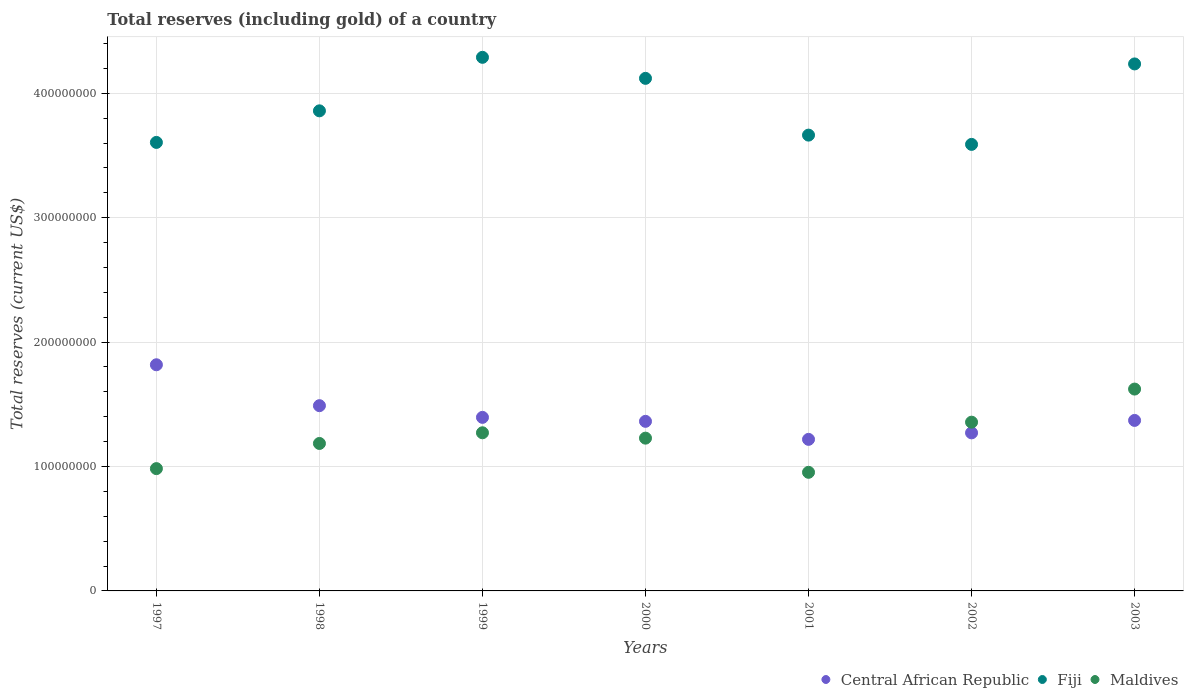What is the total reserves (including gold) in Fiji in 2001?
Offer a terse response. 3.66e+08. Across all years, what is the maximum total reserves (including gold) in Central African Republic?
Provide a short and direct response. 1.82e+08. Across all years, what is the minimum total reserves (including gold) in Fiji?
Your response must be concise. 3.59e+08. In which year was the total reserves (including gold) in Central African Republic minimum?
Offer a very short reply. 2001. What is the total total reserves (including gold) in Maldives in the graph?
Offer a very short reply. 8.60e+08. What is the difference between the total reserves (including gold) in Fiji in 2001 and that in 2003?
Give a very brief answer. -5.72e+07. What is the difference between the total reserves (including gold) in Fiji in 2001 and the total reserves (including gold) in Central African Republic in 2000?
Make the answer very short. 2.30e+08. What is the average total reserves (including gold) in Central African Republic per year?
Your answer should be compact. 1.42e+08. In the year 2003, what is the difference between the total reserves (including gold) in Fiji and total reserves (including gold) in Maldives?
Provide a short and direct response. 2.61e+08. What is the ratio of the total reserves (including gold) in Central African Republic in 1998 to that in 1999?
Provide a short and direct response. 1.07. Is the total reserves (including gold) in Central African Republic in 1998 less than that in 2001?
Keep it short and to the point. No. What is the difference between the highest and the second highest total reserves (including gold) in Fiji?
Provide a short and direct response. 5.31e+06. What is the difference between the highest and the lowest total reserves (including gold) in Central African Republic?
Give a very brief answer. 6.00e+07. In how many years, is the total reserves (including gold) in Fiji greater than the average total reserves (including gold) in Fiji taken over all years?
Keep it short and to the point. 3. Is the sum of the total reserves (including gold) in Maldives in 2001 and 2002 greater than the maximum total reserves (including gold) in Central African Republic across all years?
Keep it short and to the point. Yes. Does the total reserves (including gold) in Maldives monotonically increase over the years?
Give a very brief answer. No. Is the total reserves (including gold) in Fiji strictly greater than the total reserves (including gold) in Central African Republic over the years?
Make the answer very short. Yes. How many dotlines are there?
Your answer should be compact. 3. How many years are there in the graph?
Give a very brief answer. 7. Are the values on the major ticks of Y-axis written in scientific E-notation?
Your response must be concise. No. Does the graph contain grids?
Your answer should be compact. Yes. How are the legend labels stacked?
Your response must be concise. Horizontal. What is the title of the graph?
Provide a short and direct response. Total reserves (including gold) of a country. What is the label or title of the X-axis?
Your answer should be very brief. Years. What is the label or title of the Y-axis?
Your response must be concise. Total reserves (current US$). What is the Total reserves (current US$) of Central African Republic in 1997?
Offer a very short reply. 1.82e+08. What is the Total reserves (current US$) in Fiji in 1997?
Give a very brief answer. 3.61e+08. What is the Total reserves (current US$) of Maldives in 1997?
Offer a terse response. 9.83e+07. What is the Total reserves (current US$) in Central African Republic in 1998?
Ensure brevity in your answer.  1.49e+08. What is the Total reserves (current US$) in Fiji in 1998?
Offer a terse response. 3.86e+08. What is the Total reserves (current US$) of Maldives in 1998?
Provide a short and direct response. 1.19e+08. What is the Total reserves (current US$) of Central African Republic in 1999?
Give a very brief answer. 1.40e+08. What is the Total reserves (current US$) in Fiji in 1999?
Your answer should be very brief. 4.29e+08. What is the Total reserves (current US$) of Maldives in 1999?
Provide a short and direct response. 1.27e+08. What is the Total reserves (current US$) of Central African Republic in 2000?
Your answer should be compact. 1.36e+08. What is the Total reserves (current US$) of Fiji in 2000?
Provide a short and direct response. 4.12e+08. What is the Total reserves (current US$) of Maldives in 2000?
Offer a terse response. 1.23e+08. What is the Total reserves (current US$) of Central African Republic in 2001?
Offer a terse response. 1.22e+08. What is the Total reserves (current US$) in Fiji in 2001?
Offer a very short reply. 3.66e+08. What is the Total reserves (current US$) of Maldives in 2001?
Provide a succinct answer. 9.53e+07. What is the Total reserves (current US$) of Central African Republic in 2002?
Offer a terse response. 1.27e+08. What is the Total reserves (current US$) of Fiji in 2002?
Your answer should be compact. 3.59e+08. What is the Total reserves (current US$) in Maldives in 2002?
Your answer should be compact. 1.36e+08. What is the Total reserves (current US$) of Central African Republic in 2003?
Your response must be concise. 1.37e+08. What is the Total reserves (current US$) of Fiji in 2003?
Ensure brevity in your answer.  4.24e+08. What is the Total reserves (current US$) of Maldives in 2003?
Provide a short and direct response. 1.62e+08. Across all years, what is the maximum Total reserves (current US$) of Central African Republic?
Your response must be concise. 1.82e+08. Across all years, what is the maximum Total reserves (current US$) of Fiji?
Offer a very short reply. 4.29e+08. Across all years, what is the maximum Total reserves (current US$) in Maldives?
Your response must be concise. 1.62e+08. Across all years, what is the minimum Total reserves (current US$) of Central African Republic?
Make the answer very short. 1.22e+08. Across all years, what is the minimum Total reserves (current US$) of Fiji?
Offer a terse response. 3.59e+08. Across all years, what is the minimum Total reserves (current US$) of Maldives?
Your answer should be compact. 9.53e+07. What is the total Total reserves (current US$) of Central African Republic in the graph?
Keep it short and to the point. 9.92e+08. What is the total Total reserves (current US$) in Fiji in the graph?
Offer a terse response. 2.74e+09. What is the total Total reserves (current US$) of Maldives in the graph?
Your response must be concise. 8.60e+08. What is the difference between the Total reserves (current US$) of Central African Republic in 1997 and that in 1998?
Make the answer very short. 3.29e+07. What is the difference between the Total reserves (current US$) in Fiji in 1997 and that in 1998?
Provide a succinct answer. -2.54e+07. What is the difference between the Total reserves (current US$) in Maldives in 1997 and that in 1998?
Ensure brevity in your answer.  -2.02e+07. What is the difference between the Total reserves (current US$) in Central African Republic in 1997 and that in 1999?
Ensure brevity in your answer.  4.23e+07. What is the difference between the Total reserves (current US$) in Fiji in 1997 and that in 1999?
Keep it short and to the point. -6.84e+07. What is the difference between the Total reserves (current US$) of Maldives in 1997 and that in 1999?
Make the answer very short. -2.88e+07. What is the difference between the Total reserves (current US$) of Central African Republic in 1997 and that in 2000?
Offer a terse response. 4.55e+07. What is the difference between the Total reserves (current US$) of Fiji in 1997 and that in 2000?
Provide a succinct answer. -5.15e+07. What is the difference between the Total reserves (current US$) in Maldives in 1997 and that in 2000?
Give a very brief answer. -2.45e+07. What is the difference between the Total reserves (current US$) in Central African Republic in 1997 and that in 2001?
Offer a very short reply. 6.00e+07. What is the difference between the Total reserves (current US$) of Fiji in 1997 and that in 2001?
Keep it short and to the point. -5.86e+06. What is the difference between the Total reserves (current US$) in Maldives in 1997 and that in 2001?
Provide a succinct answer. 2.96e+06. What is the difference between the Total reserves (current US$) of Central African Republic in 1997 and that in 2002?
Ensure brevity in your answer.  5.47e+07. What is the difference between the Total reserves (current US$) of Fiji in 1997 and that in 2002?
Your answer should be compact. 1.58e+06. What is the difference between the Total reserves (current US$) of Maldives in 1997 and that in 2002?
Ensure brevity in your answer.  -3.73e+07. What is the difference between the Total reserves (current US$) of Central African Republic in 1997 and that in 2003?
Make the answer very short. 4.47e+07. What is the difference between the Total reserves (current US$) of Fiji in 1997 and that in 2003?
Your answer should be very brief. -6.31e+07. What is the difference between the Total reserves (current US$) in Maldives in 1997 and that in 2003?
Provide a short and direct response. -6.39e+07. What is the difference between the Total reserves (current US$) of Central African Republic in 1998 and that in 1999?
Keep it short and to the point. 9.40e+06. What is the difference between the Total reserves (current US$) in Fiji in 1998 and that in 1999?
Offer a terse response. -4.30e+07. What is the difference between the Total reserves (current US$) in Maldives in 1998 and that in 1999?
Offer a terse response. -8.58e+06. What is the difference between the Total reserves (current US$) of Central African Republic in 1998 and that in 2000?
Provide a short and direct response. 1.26e+07. What is the difference between the Total reserves (current US$) of Fiji in 1998 and that in 2000?
Ensure brevity in your answer.  -2.61e+07. What is the difference between the Total reserves (current US$) of Maldives in 1998 and that in 2000?
Your answer should be compact. -4.27e+06. What is the difference between the Total reserves (current US$) of Central African Republic in 1998 and that in 2001?
Offer a very short reply. 2.71e+07. What is the difference between the Total reserves (current US$) in Fiji in 1998 and that in 2001?
Your answer should be compact. 1.95e+07. What is the difference between the Total reserves (current US$) in Maldives in 1998 and that in 2001?
Your answer should be very brief. 2.32e+07. What is the difference between the Total reserves (current US$) in Central African Republic in 1998 and that in 2002?
Provide a short and direct response. 2.19e+07. What is the difference between the Total reserves (current US$) in Fiji in 1998 and that in 2002?
Offer a terse response. 2.70e+07. What is the difference between the Total reserves (current US$) of Maldives in 1998 and that in 2002?
Your response must be concise. -1.71e+07. What is the difference between the Total reserves (current US$) in Central African Republic in 1998 and that in 2003?
Your answer should be compact. 1.19e+07. What is the difference between the Total reserves (current US$) of Fiji in 1998 and that in 2003?
Provide a succinct answer. -3.77e+07. What is the difference between the Total reserves (current US$) of Maldives in 1998 and that in 2003?
Your answer should be compact. -4.37e+07. What is the difference between the Total reserves (current US$) in Central African Republic in 1999 and that in 2000?
Your answer should be compact. 3.20e+06. What is the difference between the Total reserves (current US$) of Fiji in 1999 and that in 2000?
Offer a very short reply. 1.69e+07. What is the difference between the Total reserves (current US$) in Maldives in 1999 and that in 2000?
Your answer should be compact. 4.32e+06. What is the difference between the Total reserves (current US$) of Central African Republic in 1999 and that in 2001?
Make the answer very short. 1.77e+07. What is the difference between the Total reserves (current US$) in Fiji in 1999 and that in 2001?
Your answer should be very brief. 6.25e+07. What is the difference between the Total reserves (current US$) of Maldives in 1999 and that in 2001?
Provide a succinct answer. 3.18e+07. What is the difference between the Total reserves (current US$) in Central African Republic in 1999 and that in 2002?
Provide a succinct answer. 1.25e+07. What is the difference between the Total reserves (current US$) of Fiji in 1999 and that in 2002?
Provide a short and direct response. 7.00e+07. What is the difference between the Total reserves (current US$) of Maldives in 1999 and that in 2002?
Give a very brief answer. -8.52e+06. What is the difference between the Total reserves (current US$) in Central African Republic in 1999 and that in 2003?
Ensure brevity in your answer.  2.45e+06. What is the difference between the Total reserves (current US$) in Fiji in 1999 and that in 2003?
Keep it short and to the point. 5.31e+06. What is the difference between the Total reserves (current US$) in Maldives in 1999 and that in 2003?
Keep it short and to the point. -3.51e+07. What is the difference between the Total reserves (current US$) in Central African Republic in 2000 and that in 2001?
Provide a short and direct response. 1.45e+07. What is the difference between the Total reserves (current US$) of Fiji in 2000 and that in 2001?
Offer a terse response. 4.56e+07. What is the difference between the Total reserves (current US$) in Maldives in 2000 and that in 2001?
Provide a succinct answer. 2.75e+07. What is the difference between the Total reserves (current US$) in Central African Republic in 2000 and that in 2002?
Provide a short and direct response. 9.26e+06. What is the difference between the Total reserves (current US$) in Fiji in 2000 and that in 2002?
Provide a short and direct response. 5.31e+07. What is the difference between the Total reserves (current US$) of Maldives in 2000 and that in 2002?
Provide a succinct answer. -1.28e+07. What is the difference between the Total reserves (current US$) in Central African Republic in 2000 and that in 2003?
Your answer should be very brief. -7.42e+05. What is the difference between the Total reserves (current US$) in Fiji in 2000 and that in 2003?
Keep it short and to the point. -1.16e+07. What is the difference between the Total reserves (current US$) of Maldives in 2000 and that in 2003?
Make the answer very short. -3.94e+07. What is the difference between the Total reserves (current US$) of Central African Republic in 2001 and that in 2002?
Your answer should be compact. -5.22e+06. What is the difference between the Total reserves (current US$) in Fiji in 2001 and that in 2002?
Offer a terse response. 7.45e+06. What is the difference between the Total reserves (current US$) in Maldives in 2001 and that in 2002?
Offer a very short reply. -4.03e+07. What is the difference between the Total reserves (current US$) of Central African Republic in 2001 and that in 2003?
Your answer should be compact. -1.52e+07. What is the difference between the Total reserves (current US$) of Fiji in 2001 and that in 2003?
Make the answer very short. -5.72e+07. What is the difference between the Total reserves (current US$) in Maldives in 2001 and that in 2003?
Your answer should be compact. -6.69e+07. What is the difference between the Total reserves (current US$) in Central African Republic in 2002 and that in 2003?
Offer a terse response. -1.00e+07. What is the difference between the Total reserves (current US$) of Fiji in 2002 and that in 2003?
Offer a very short reply. -6.47e+07. What is the difference between the Total reserves (current US$) in Maldives in 2002 and that in 2003?
Offer a terse response. -2.66e+07. What is the difference between the Total reserves (current US$) in Central African Republic in 1997 and the Total reserves (current US$) in Fiji in 1998?
Ensure brevity in your answer.  -2.04e+08. What is the difference between the Total reserves (current US$) of Central African Republic in 1997 and the Total reserves (current US$) of Maldives in 1998?
Your answer should be very brief. 6.33e+07. What is the difference between the Total reserves (current US$) in Fiji in 1997 and the Total reserves (current US$) in Maldives in 1998?
Your response must be concise. 2.42e+08. What is the difference between the Total reserves (current US$) in Central African Republic in 1997 and the Total reserves (current US$) in Fiji in 1999?
Provide a succinct answer. -2.47e+08. What is the difference between the Total reserves (current US$) of Central African Republic in 1997 and the Total reserves (current US$) of Maldives in 1999?
Your answer should be very brief. 5.47e+07. What is the difference between the Total reserves (current US$) in Fiji in 1997 and the Total reserves (current US$) in Maldives in 1999?
Offer a very short reply. 2.33e+08. What is the difference between the Total reserves (current US$) of Central African Republic in 1997 and the Total reserves (current US$) of Fiji in 2000?
Your response must be concise. -2.30e+08. What is the difference between the Total reserves (current US$) of Central African Republic in 1997 and the Total reserves (current US$) of Maldives in 2000?
Provide a succinct answer. 5.90e+07. What is the difference between the Total reserves (current US$) in Fiji in 1997 and the Total reserves (current US$) in Maldives in 2000?
Your answer should be very brief. 2.38e+08. What is the difference between the Total reserves (current US$) of Central African Republic in 1997 and the Total reserves (current US$) of Fiji in 2001?
Offer a very short reply. -1.85e+08. What is the difference between the Total reserves (current US$) in Central African Republic in 1997 and the Total reserves (current US$) in Maldives in 2001?
Your response must be concise. 8.64e+07. What is the difference between the Total reserves (current US$) of Fiji in 1997 and the Total reserves (current US$) of Maldives in 2001?
Provide a succinct answer. 2.65e+08. What is the difference between the Total reserves (current US$) in Central African Republic in 1997 and the Total reserves (current US$) in Fiji in 2002?
Provide a succinct answer. -1.77e+08. What is the difference between the Total reserves (current US$) of Central African Republic in 1997 and the Total reserves (current US$) of Maldives in 2002?
Your answer should be very brief. 4.61e+07. What is the difference between the Total reserves (current US$) in Fiji in 1997 and the Total reserves (current US$) in Maldives in 2002?
Give a very brief answer. 2.25e+08. What is the difference between the Total reserves (current US$) of Central African Republic in 1997 and the Total reserves (current US$) of Fiji in 2003?
Keep it short and to the point. -2.42e+08. What is the difference between the Total reserves (current US$) of Central African Republic in 1997 and the Total reserves (current US$) of Maldives in 2003?
Your response must be concise. 1.95e+07. What is the difference between the Total reserves (current US$) of Fiji in 1997 and the Total reserves (current US$) of Maldives in 2003?
Ensure brevity in your answer.  1.98e+08. What is the difference between the Total reserves (current US$) in Central African Republic in 1998 and the Total reserves (current US$) in Fiji in 1999?
Make the answer very short. -2.80e+08. What is the difference between the Total reserves (current US$) in Central African Republic in 1998 and the Total reserves (current US$) in Maldives in 1999?
Make the answer very short. 2.18e+07. What is the difference between the Total reserves (current US$) in Fiji in 1998 and the Total reserves (current US$) in Maldives in 1999?
Keep it short and to the point. 2.59e+08. What is the difference between the Total reserves (current US$) in Central African Republic in 1998 and the Total reserves (current US$) in Fiji in 2000?
Offer a very short reply. -2.63e+08. What is the difference between the Total reserves (current US$) of Central African Republic in 1998 and the Total reserves (current US$) of Maldives in 2000?
Make the answer very short. 2.61e+07. What is the difference between the Total reserves (current US$) of Fiji in 1998 and the Total reserves (current US$) of Maldives in 2000?
Make the answer very short. 2.63e+08. What is the difference between the Total reserves (current US$) of Central African Republic in 1998 and the Total reserves (current US$) of Fiji in 2001?
Offer a very short reply. -2.17e+08. What is the difference between the Total reserves (current US$) of Central African Republic in 1998 and the Total reserves (current US$) of Maldives in 2001?
Make the answer very short. 5.36e+07. What is the difference between the Total reserves (current US$) in Fiji in 1998 and the Total reserves (current US$) in Maldives in 2001?
Provide a succinct answer. 2.91e+08. What is the difference between the Total reserves (current US$) of Central African Republic in 1998 and the Total reserves (current US$) of Fiji in 2002?
Give a very brief answer. -2.10e+08. What is the difference between the Total reserves (current US$) of Central African Republic in 1998 and the Total reserves (current US$) of Maldives in 2002?
Make the answer very short. 1.33e+07. What is the difference between the Total reserves (current US$) of Fiji in 1998 and the Total reserves (current US$) of Maldives in 2002?
Make the answer very short. 2.50e+08. What is the difference between the Total reserves (current US$) of Central African Republic in 1998 and the Total reserves (current US$) of Fiji in 2003?
Your answer should be compact. -2.75e+08. What is the difference between the Total reserves (current US$) in Central African Republic in 1998 and the Total reserves (current US$) in Maldives in 2003?
Keep it short and to the point. -1.33e+07. What is the difference between the Total reserves (current US$) in Fiji in 1998 and the Total reserves (current US$) in Maldives in 2003?
Provide a short and direct response. 2.24e+08. What is the difference between the Total reserves (current US$) of Central African Republic in 1999 and the Total reserves (current US$) of Fiji in 2000?
Make the answer very short. -2.73e+08. What is the difference between the Total reserves (current US$) of Central African Republic in 1999 and the Total reserves (current US$) of Maldives in 2000?
Offer a terse response. 1.67e+07. What is the difference between the Total reserves (current US$) in Fiji in 1999 and the Total reserves (current US$) in Maldives in 2000?
Offer a very short reply. 3.06e+08. What is the difference between the Total reserves (current US$) in Central African Republic in 1999 and the Total reserves (current US$) in Fiji in 2001?
Ensure brevity in your answer.  -2.27e+08. What is the difference between the Total reserves (current US$) of Central African Republic in 1999 and the Total reserves (current US$) of Maldives in 2001?
Provide a short and direct response. 4.42e+07. What is the difference between the Total reserves (current US$) of Fiji in 1999 and the Total reserves (current US$) of Maldives in 2001?
Your response must be concise. 3.34e+08. What is the difference between the Total reserves (current US$) in Central African Republic in 1999 and the Total reserves (current US$) in Fiji in 2002?
Make the answer very short. -2.19e+08. What is the difference between the Total reserves (current US$) of Central African Republic in 1999 and the Total reserves (current US$) of Maldives in 2002?
Offer a terse response. 3.87e+06. What is the difference between the Total reserves (current US$) in Fiji in 1999 and the Total reserves (current US$) in Maldives in 2002?
Your answer should be compact. 2.93e+08. What is the difference between the Total reserves (current US$) in Central African Republic in 1999 and the Total reserves (current US$) in Fiji in 2003?
Provide a short and direct response. -2.84e+08. What is the difference between the Total reserves (current US$) in Central African Republic in 1999 and the Total reserves (current US$) in Maldives in 2003?
Your answer should be very brief. -2.27e+07. What is the difference between the Total reserves (current US$) in Fiji in 1999 and the Total reserves (current US$) in Maldives in 2003?
Make the answer very short. 2.67e+08. What is the difference between the Total reserves (current US$) of Central African Republic in 2000 and the Total reserves (current US$) of Fiji in 2001?
Provide a succinct answer. -2.30e+08. What is the difference between the Total reserves (current US$) of Central African Republic in 2000 and the Total reserves (current US$) of Maldives in 2001?
Your answer should be very brief. 4.10e+07. What is the difference between the Total reserves (current US$) of Fiji in 2000 and the Total reserves (current US$) of Maldives in 2001?
Offer a terse response. 3.17e+08. What is the difference between the Total reserves (current US$) in Central African Republic in 2000 and the Total reserves (current US$) in Fiji in 2002?
Your response must be concise. -2.23e+08. What is the difference between the Total reserves (current US$) of Central African Republic in 2000 and the Total reserves (current US$) of Maldives in 2002?
Ensure brevity in your answer.  6.73e+05. What is the difference between the Total reserves (current US$) of Fiji in 2000 and the Total reserves (current US$) of Maldives in 2002?
Your answer should be compact. 2.76e+08. What is the difference between the Total reserves (current US$) of Central African Republic in 2000 and the Total reserves (current US$) of Fiji in 2003?
Offer a very short reply. -2.87e+08. What is the difference between the Total reserves (current US$) in Central African Republic in 2000 and the Total reserves (current US$) in Maldives in 2003?
Your answer should be very brief. -2.59e+07. What is the difference between the Total reserves (current US$) in Fiji in 2000 and the Total reserves (current US$) in Maldives in 2003?
Ensure brevity in your answer.  2.50e+08. What is the difference between the Total reserves (current US$) in Central African Republic in 2001 and the Total reserves (current US$) in Fiji in 2002?
Provide a succinct answer. -2.37e+08. What is the difference between the Total reserves (current US$) of Central African Republic in 2001 and the Total reserves (current US$) of Maldives in 2002?
Offer a very short reply. -1.38e+07. What is the difference between the Total reserves (current US$) of Fiji in 2001 and the Total reserves (current US$) of Maldives in 2002?
Provide a short and direct response. 2.31e+08. What is the difference between the Total reserves (current US$) in Central African Republic in 2001 and the Total reserves (current US$) in Fiji in 2003?
Your response must be concise. -3.02e+08. What is the difference between the Total reserves (current US$) of Central African Republic in 2001 and the Total reserves (current US$) of Maldives in 2003?
Your answer should be very brief. -4.04e+07. What is the difference between the Total reserves (current US$) of Fiji in 2001 and the Total reserves (current US$) of Maldives in 2003?
Offer a very short reply. 2.04e+08. What is the difference between the Total reserves (current US$) in Central African Republic in 2002 and the Total reserves (current US$) in Fiji in 2003?
Your answer should be compact. -2.97e+08. What is the difference between the Total reserves (current US$) in Central African Republic in 2002 and the Total reserves (current US$) in Maldives in 2003?
Offer a very short reply. -3.52e+07. What is the difference between the Total reserves (current US$) of Fiji in 2002 and the Total reserves (current US$) of Maldives in 2003?
Give a very brief answer. 1.97e+08. What is the average Total reserves (current US$) in Central African Republic per year?
Give a very brief answer. 1.42e+08. What is the average Total reserves (current US$) in Fiji per year?
Keep it short and to the point. 3.91e+08. What is the average Total reserves (current US$) of Maldives per year?
Make the answer very short. 1.23e+08. In the year 1997, what is the difference between the Total reserves (current US$) of Central African Republic and Total reserves (current US$) of Fiji?
Offer a terse response. -1.79e+08. In the year 1997, what is the difference between the Total reserves (current US$) of Central African Republic and Total reserves (current US$) of Maldives?
Ensure brevity in your answer.  8.35e+07. In the year 1997, what is the difference between the Total reserves (current US$) of Fiji and Total reserves (current US$) of Maldives?
Provide a succinct answer. 2.62e+08. In the year 1998, what is the difference between the Total reserves (current US$) in Central African Republic and Total reserves (current US$) in Fiji?
Ensure brevity in your answer.  -2.37e+08. In the year 1998, what is the difference between the Total reserves (current US$) in Central African Republic and Total reserves (current US$) in Maldives?
Your answer should be very brief. 3.04e+07. In the year 1998, what is the difference between the Total reserves (current US$) of Fiji and Total reserves (current US$) of Maldives?
Your answer should be compact. 2.67e+08. In the year 1999, what is the difference between the Total reserves (current US$) in Central African Republic and Total reserves (current US$) in Fiji?
Offer a terse response. -2.89e+08. In the year 1999, what is the difference between the Total reserves (current US$) in Central African Republic and Total reserves (current US$) in Maldives?
Give a very brief answer. 1.24e+07. In the year 1999, what is the difference between the Total reserves (current US$) in Fiji and Total reserves (current US$) in Maldives?
Your answer should be very brief. 3.02e+08. In the year 2000, what is the difference between the Total reserves (current US$) of Central African Republic and Total reserves (current US$) of Fiji?
Make the answer very short. -2.76e+08. In the year 2000, what is the difference between the Total reserves (current US$) of Central African Republic and Total reserves (current US$) of Maldives?
Keep it short and to the point. 1.35e+07. In the year 2000, what is the difference between the Total reserves (current US$) of Fiji and Total reserves (current US$) of Maldives?
Provide a succinct answer. 2.89e+08. In the year 2001, what is the difference between the Total reserves (current US$) of Central African Republic and Total reserves (current US$) of Fiji?
Your response must be concise. -2.45e+08. In the year 2001, what is the difference between the Total reserves (current US$) in Central African Republic and Total reserves (current US$) in Maldives?
Your response must be concise. 2.65e+07. In the year 2001, what is the difference between the Total reserves (current US$) of Fiji and Total reserves (current US$) of Maldives?
Ensure brevity in your answer.  2.71e+08. In the year 2002, what is the difference between the Total reserves (current US$) of Central African Republic and Total reserves (current US$) of Fiji?
Give a very brief answer. -2.32e+08. In the year 2002, what is the difference between the Total reserves (current US$) of Central African Republic and Total reserves (current US$) of Maldives?
Your response must be concise. -8.59e+06. In the year 2002, what is the difference between the Total reserves (current US$) of Fiji and Total reserves (current US$) of Maldives?
Your answer should be very brief. 2.23e+08. In the year 2003, what is the difference between the Total reserves (current US$) of Central African Republic and Total reserves (current US$) of Fiji?
Provide a short and direct response. -2.87e+08. In the year 2003, what is the difference between the Total reserves (current US$) in Central African Republic and Total reserves (current US$) in Maldives?
Ensure brevity in your answer.  -2.52e+07. In the year 2003, what is the difference between the Total reserves (current US$) in Fiji and Total reserves (current US$) in Maldives?
Give a very brief answer. 2.61e+08. What is the ratio of the Total reserves (current US$) of Central African Republic in 1997 to that in 1998?
Make the answer very short. 1.22. What is the ratio of the Total reserves (current US$) of Fiji in 1997 to that in 1998?
Your answer should be very brief. 0.93. What is the ratio of the Total reserves (current US$) of Maldives in 1997 to that in 1998?
Offer a very short reply. 0.83. What is the ratio of the Total reserves (current US$) in Central African Republic in 1997 to that in 1999?
Your response must be concise. 1.3. What is the ratio of the Total reserves (current US$) in Fiji in 1997 to that in 1999?
Give a very brief answer. 0.84. What is the ratio of the Total reserves (current US$) of Maldives in 1997 to that in 1999?
Keep it short and to the point. 0.77. What is the ratio of the Total reserves (current US$) of Central African Republic in 1997 to that in 2000?
Offer a terse response. 1.33. What is the ratio of the Total reserves (current US$) of Fiji in 1997 to that in 2000?
Provide a succinct answer. 0.88. What is the ratio of the Total reserves (current US$) of Maldives in 1997 to that in 2000?
Offer a very short reply. 0.8. What is the ratio of the Total reserves (current US$) in Central African Republic in 1997 to that in 2001?
Make the answer very short. 1.49. What is the ratio of the Total reserves (current US$) of Fiji in 1997 to that in 2001?
Your answer should be compact. 0.98. What is the ratio of the Total reserves (current US$) of Maldives in 1997 to that in 2001?
Provide a short and direct response. 1.03. What is the ratio of the Total reserves (current US$) in Central African Republic in 1997 to that in 2002?
Keep it short and to the point. 1.43. What is the ratio of the Total reserves (current US$) in Fiji in 1997 to that in 2002?
Ensure brevity in your answer.  1. What is the ratio of the Total reserves (current US$) in Maldives in 1997 to that in 2002?
Keep it short and to the point. 0.72. What is the ratio of the Total reserves (current US$) of Central African Republic in 1997 to that in 2003?
Ensure brevity in your answer.  1.33. What is the ratio of the Total reserves (current US$) of Fiji in 1997 to that in 2003?
Ensure brevity in your answer.  0.85. What is the ratio of the Total reserves (current US$) in Maldives in 1997 to that in 2003?
Your answer should be compact. 0.61. What is the ratio of the Total reserves (current US$) in Central African Republic in 1998 to that in 1999?
Your answer should be compact. 1.07. What is the ratio of the Total reserves (current US$) of Fiji in 1998 to that in 1999?
Your answer should be very brief. 0.9. What is the ratio of the Total reserves (current US$) of Maldives in 1998 to that in 1999?
Your answer should be very brief. 0.93. What is the ratio of the Total reserves (current US$) in Central African Republic in 1998 to that in 2000?
Give a very brief answer. 1.09. What is the ratio of the Total reserves (current US$) of Fiji in 1998 to that in 2000?
Provide a short and direct response. 0.94. What is the ratio of the Total reserves (current US$) in Maldives in 1998 to that in 2000?
Your answer should be very brief. 0.97. What is the ratio of the Total reserves (current US$) of Central African Republic in 1998 to that in 2001?
Your answer should be very brief. 1.22. What is the ratio of the Total reserves (current US$) in Fiji in 1998 to that in 2001?
Make the answer very short. 1.05. What is the ratio of the Total reserves (current US$) of Maldives in 1998 to that in 2001?
Your answer should be very brief. 1.24. What is the ratio of the Total reserves (current US$) in Central African Republic in 1998 to that in 2002?
Make the answer very short. 1.17. What is the ratio of the Total reserves (current US$) of Fiji in 1998 to that in 2002?
Offer a terse response. 1.08. What is the ratio of the Total reserves (current US$) in Maldives in 1998 to that in 2002?
Offer a very short reply. 0.87. What is the ratio of the Total reserves (current US$) of Central African Republic in 1998 to that in 2003?
Keep it short and to the point. 1.09. What is the ratio of the Total reserves (current US$) in Fiji in 1998 to that in 2003?
Make the answer very short. 0.91. What is the ratio of the Total reserves (current US$) of Maldives in 1998 to that in 2003?
Your answer should be compact. 0.73. What is the ratio of the Total reserves (current US$) of Central African Republic in 1999 to that in 2000?
Offer a very short reply. 1.02. What is the ratio of the Total reserves (current US$) in Fiji in 1999 to that in 2000?
Offer a terse response. 1.04. What is the ratio of the Total reserves (current US$) of Maldives in 1999 to that in 2000?
Offer a very short reply. 1.04. What is the ratio of the Total reserves (current US$) in Central African Republic in 1999 to that in 2001?
Provide a succinct answer. 1.15. What is the ratio of the Total reserves (current US$) in Fiji in 1999 to that in 2001?
Make the answer very short. 1.17. What is the ratio of the Total reserves (current US$) in Maldives in 1999 to that in 2001?
Provide a short and direct response. 1.33. What is the ratio of the Total reserves (current US$) in Central African Republic in 1999 to that in 2002?
Offer a terse response. 1.1. What is the ratio of the Total reserves (current US$) in Fiji in 1999 to that in 2002?
Provide a short and direct response. 1.2. What is the ratio of the Total reserves (current US$) in Maldives in 1999 to that in 2002?
Keep it short and to the point. 0.94. What is the ratio of the Total reserves (current US$) in Central African Republic in 1999 to that in 2003?
Your answer should be very brief. 1.02. What is the ratio of the Total reserves (current US$) of Fiji in 1999 to that in 2003?
Provide a succinct answer. 1.01. What is the ratio of the Total reserves (current US$) in Maldives in 1999 to that in 2003?
Make the answer very short. 0.78. What is the ratio of the Total reserves (current US$) in Central African Republic in 2000 to that in 2001?
Keep it short and to the point. 1.12. What is the ratio of the Total reserves (current US$) in Fiji in 2000 to that in 2001?
Offer a very short reply. 1.12. What is the ratio of the Total reserves (current US$) of Maldives in 2000 to that in 2001?
Make the answer very short. 1.29. What is the ratio of the Total reserves (current US$) in Central African Republic in 2000 to that in 2002?
Give a very brief answer. 1.07. What is the ratio of the Total reserves (current US$) of Fiji in 2000 to that in 2002?
Ensure brevity in your answer.  1.15. What is the ratio of the Total reserves (current US$) of Maldives in 2000 to that in 2002?
Your answer should be compact. 0.91. What is the ratio of the Total reserves (current US$) of Central African Republic in 2000 to that in 2003?
Keep it short and to the point. 0.99. What is the ratio of the Total reserves (current US$) of Fiji in 2000 to that in 2003?
Ensure brevity in your answer.  0.97. What is the ratio of the Total reserves (current US$) in Maldives in 2000 to that in 2003?
Ensure brevity in your answer.  0.76. What is the ratio of the Total reserves (current US$) of Central African Republic in 2001 to that in 2002?
Provide a succinct answer. 0.96. What is the ratio of the Total reserves (current US$) of Fiji in 2001 to that in 2002?
Give a very brief answer. 1.02. What is the ratio of the Total reserves (current US$) of Maldives in 2001 to that in 2002?
Your response must be concise. 0.7. What is the ratio of the Total reserves (current US$) of Central African Republic in 2001 to that in 2003?
Ensure brevity in your answer.  0.89. What is the ratio of the Total reserves (current US$) in Fiji in 2001 to that in 2003?
Your answer should be very brief. 0.86. What is the ratio of the Total reserves (current US$) in Maldives in 2001 to that in 2003?
Your answer should be very brief. 0.59. What is the ratio of the Total reserves (current US$) in Central African Republic in 2002 to that in 2003?
Keep it short and to the point. 0.93. What is the ratio of the Total reserves (current US$) in Fiji in 2002 to that in 2003?
Provide a short and direct response. 0.85. What is the ratio of the Total reserves (current US$) of Maldives in 2002 to that in 2003?
Give a very brief answer. 0.84. What is the difference between the highest and the second highest Total reserves (current US$) of Central African Republic?
Your answer should be compact. 3.29e+07. What is the difference between the highest and the second highest Total reserves (current US$) in Fiji?
Offer a very short reply. 5.31e+06. What is the difference between the highest and the second highest Total reserves (current US$) of Maldives?
Make the answer very short. 2.66e+07. What is the difference between the highest and the lowest Total reserves (current US$) of Central African Republic?
Offer a terse response. 6.00e+07. What is the difference between the highest and the lowest Total reserves (current US$) in Fiji?
Ensure brevity in your answer.  7.00e+07. What is the difference between the highest and the lowest Total reserves (current US$) in Maldives?
Make the answer very short. 6.69e+07. 